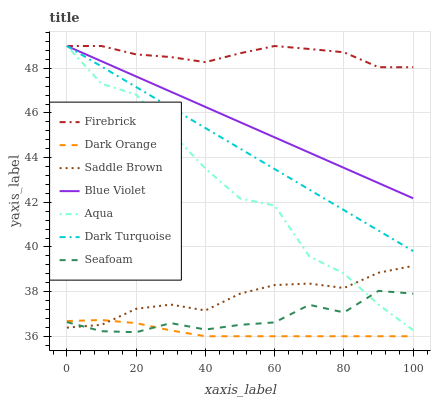Does Dark Turquoise have the minimum area under the curve?
Answer yes or no. No. Does Dark Turquoise have the maximum area under the curve?
Answer yes or no. No. Is Firebrick the smoothest?
Answer yes or no. No. Is Firebrick the roughest?
Answer yes or no. No. Does Dark Turquoise have the lowest value?
Answer yes or no. No. Does Seafoam have the highest value?
Answer yes or no. No. Is Dark Orange less than Blue Violet?
Answer yes or no. Yes. Is Aqua greater than Dark Orange?
Answer yes or no. Yes. Does Dark Orange intersect Blue Violet?
Answer yes or no. No. 